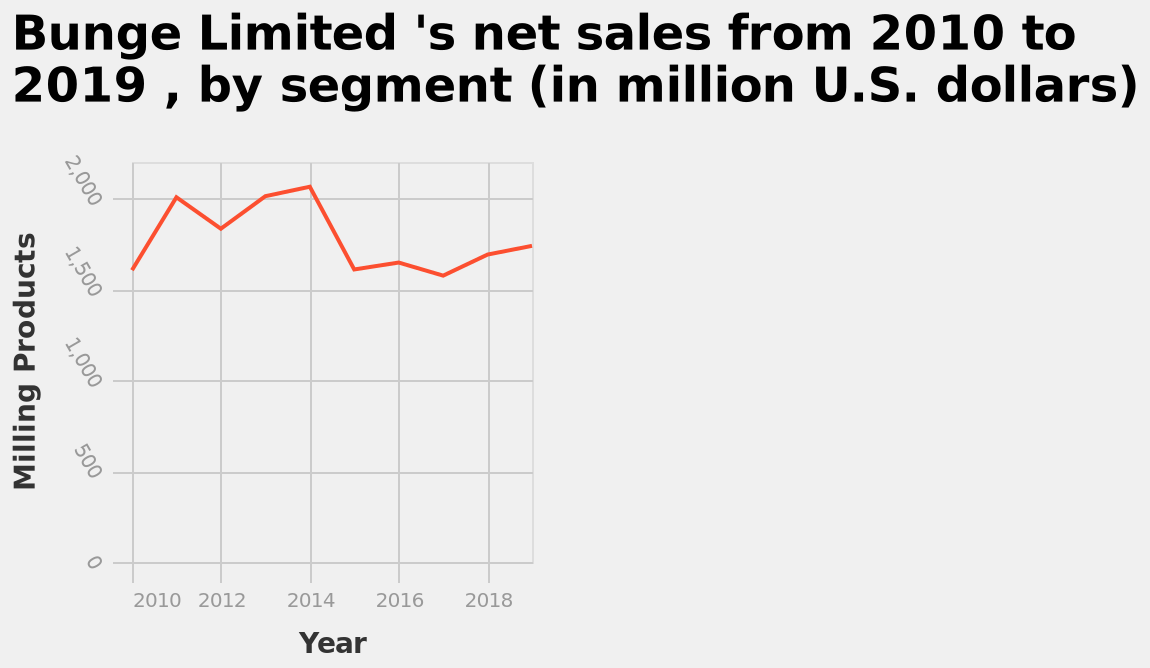<image>
What was the net sales of Milling Products for Bunge Limited in 2015?  By examining the line graph, the net sales of Milling Products for Bunge Limited in 2015 can be determined. What was the highest number of sales achieved by Bunge Limited in the set period?  The highest number of sales achieved by Bunge Limited in the set period was 2100 in 2014. 